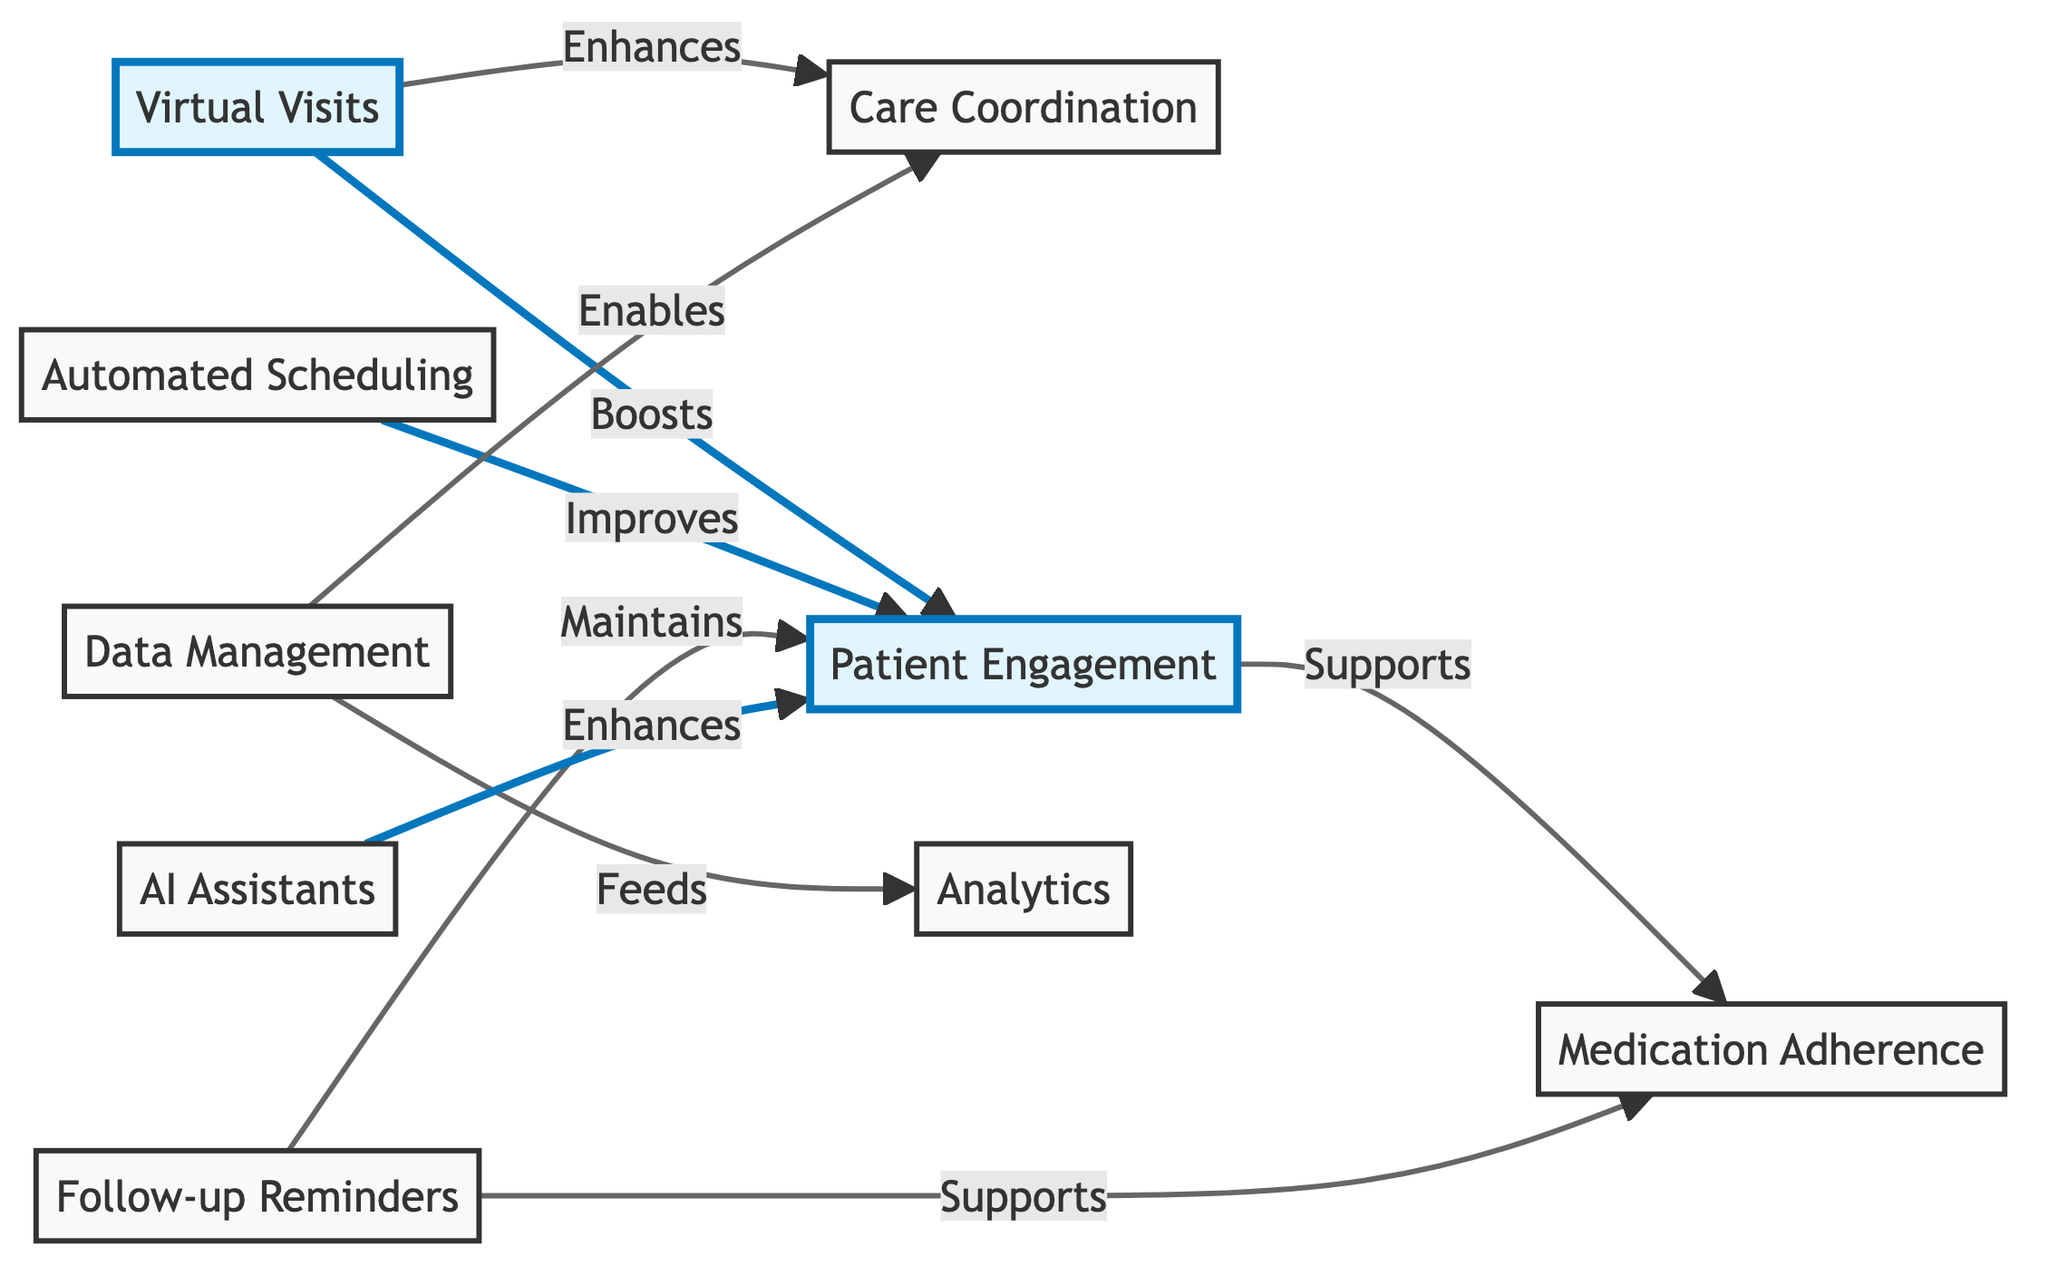What are the components that enhance patient engagement? The diagram indicates that patient engagement is enhanced by virtual visits and AI assistants. These connections show a direct influence on the level of patient participation in the care process.
Answer: virtual visits, AI assistants How many main components are there in the diagram? Counting the individual nodes in the diagram reveals that there are eight main components, including virtual visits, care coordination, patient engagement, automated scheduling, follow-up reminders, data management, analytics, and medication adherence.
Answer: eight Which component directly supports medication adherence? The diagram shows that both patient engagement and follow-up reminders directly support medication adherence, indicating that maintaining patient involvement and ensuring reminders contribute to medication compliance.
Answer: patient engagement, follow-up reminders What does data management enable in the diagram? According to the diagram, data management enables care coordination, illustrating the role of data in facilitating better organized patient care processes.
Answer: care coordination How do automated scheduling and follow-up reminders interact with patient engagement? The diagram illustrates that automated scheduling improves patient engagement and follow-up reminders maintain patient engagement, highlighting the importance of these functions in keeping patients involved in their care.
Answer: improves, maintains Which two components are linked to data management? The diagram shows that data management feeds analytics and enables care coordination, indicating its dual role in both analyzing patient data and facilitating coordinated care efforts.
Answer: analytics, care coordination What enhances care coordination in this diagram? Virtual visits enhance care coordination as per the diagram, showing how digital interactions can facilitate better management of care among providers and patients.
Answer: virtual visits Which component shows a direct relationship with analytics? The diagram indicates that data management feeds into analytics, demonstrating how information management underlines the analytical processes within the telehealth framework.
Answer: data management 